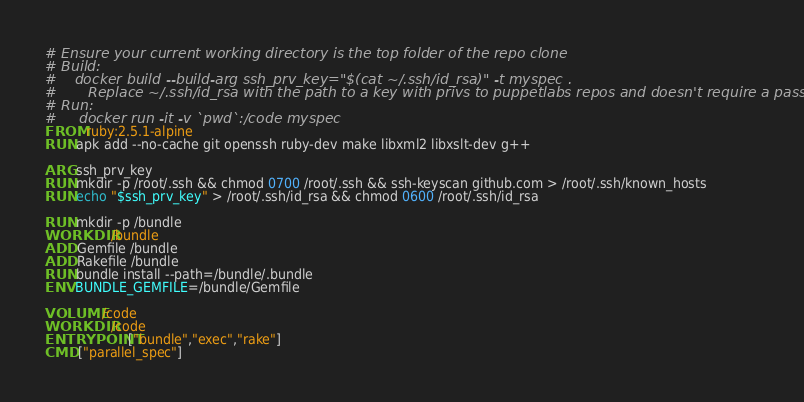<code> <loc_0><loc_0><loc_500><loc_500><_Dockerfile_># Ensure your current working directory is the top folder of the repo clone
# Build:
#    docker build --build-arg ssh_prv_key="$(cat ~/.ssh/id_rsa)" -t myspec .
#       Replace ~/.ssh/id_rsa with the path to a key with privs to puppetlabs repos and doesn't require a password
# Run:
#     docker run -it -v `pwd`:/code myspec
FROM ruby:2.5.1-alpine
RUN apk add --no-cache git openssh ruby-dev make libxml2 libxslt-dev g++

ARG ssh_prv_key
RUN mkdir -p /root/.ssh && chmod 0700 /root/.ssh && ssh-keyscan github.com > /root/.ssh/known_hosts
RUN echo "$ssh_prv_key" > /root/.ssh/id_rsa && chmod 0600 /root/.ssh/id_rsa

RUN mkdir -p /bundle
WORKDIR /bundle
ADD Gemfile /bundle
ADD Rakefile /bundle
RUN bundle install --path=/bundle/.bundle
ENV BUNDLE_GEMFILE=/bundle/Gemfile

VOLUME /code
WORKDIR /code
ENTRYPOINT ["bundle","exec","rake"]
CMD ["parallel_spec"]
</code> 